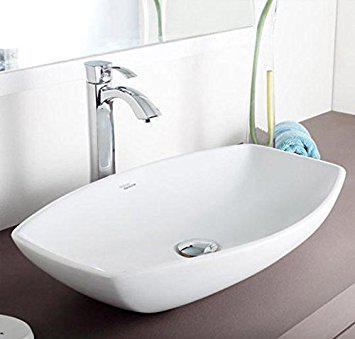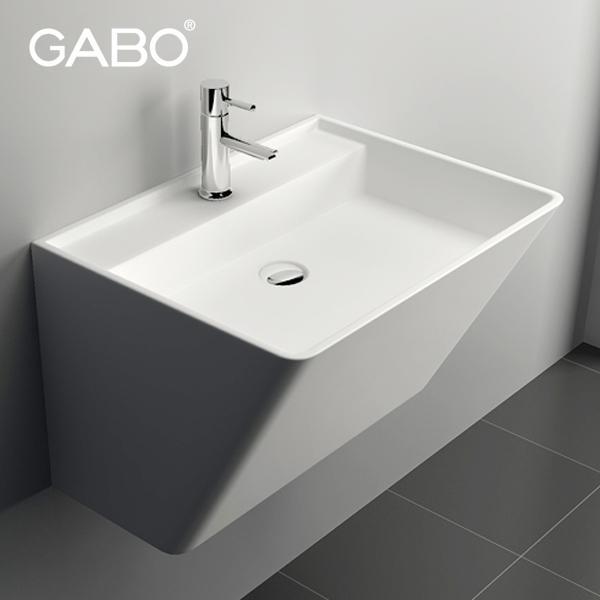The first image is the image on the left, the second image is the image on the right. For the images displayed, is the sentence "There are at least two rectangular basins." factually correct? Answer yes or no. No. The first image is the image on the left, the second image is the image on the right. Analyze the images presented: Is the assertion "An image shows at least one square white sink atop a black base and under a spout mounted to the wall." valid? Answer yes or no. No. 